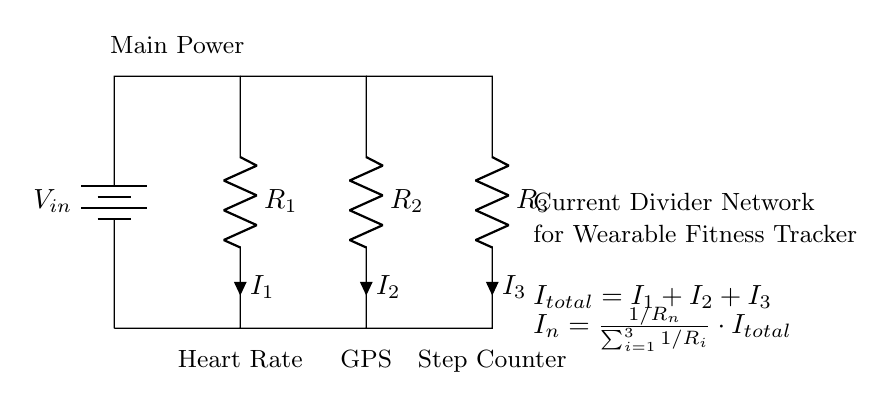What is the total current flowing in the circuit? The total current is represented as I total, which is the sum of the individual currents I1, I2, and I3. It is crucial to identify that this total current is the input to the current divider network.
Answer: I total What component provides the input voltage in this circuit? The input voltage is provided by the battery, which is labeled as V in. It is the source that initiates the current flow through the circuit.
Answer: Battery How many resistors are in this current divider? There are three resistors in the current divider network, labeled as R1, R2, and R3. These resistors are crucial for dividing the current among different pathways.
Answer: Three What is the function of R2 in the circuit? R2 is one of the resistors in the current divider, and it carries its own current I2, which is a portion of the total current. Its resistance impacts how much current flows through it compared to the others.
Answer: Divides current How is the current through one of the resistors calculated? The current through resistor Rn is calculated using the formula I n = (1/Rn) / (sum of 1/Ri for all resistors) multiplied by I total. This formula effectively distributes current based on resistance values.
Answer: I n formula What does the current divider formula imply about total current distribution? The current divider formula indicates that the total current is distributed inversely to the resistance values of the individual resistors. Lower resistance results in higher current through that path.
Answer: Inversely proportional 